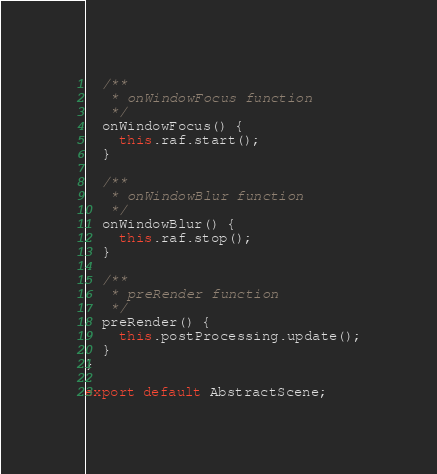Convert code to text. <code><loc_0><loc_0><loc_500><loc_500><_JavaScript_>  /**
   * onWindowFocus function
   */
  onWindowFocus() {
    this.raf.start();
  }

  /**
   * onWindowBlur function
   */
  onWindowBlur() {
    this.raf.stop();
  }

  /**
   * preRender function
   */
  preRender() {
    this.postProcessing.update();
  }
}

export default AbstractScene;
</code> 